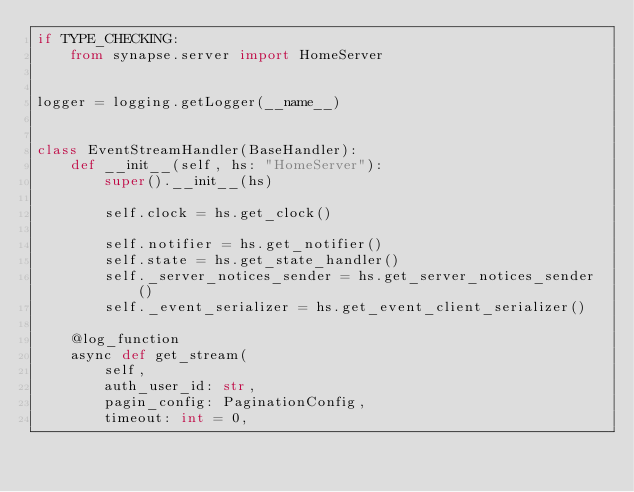Convert code to text. <code><loc_0><loc_0><loc_500><loc_500><_Python_>if TYPE_CHECKING:
    from synapse.server import HomeServer


logger = logging.getLogger(__name__)


class EventStreamHandler(BaseHandler):
    def __init__(self, hs: "HomeServer"):
        super().__init__(hs)

        self.clock = hs.get_clock()

        self.notifier = hs.get_notifier()
        self.state = hs.get_state_handler()
        self._server_notices_sender = hs.get_server_notices_sender()
        self._event_serializer = hs.get_event_client_serializer()

    @log_function
    async def get_stream(
        self,
        auth_user_id: str,
        pagin_config: PaginationConfig,
        timeout: int = 0,</code> 